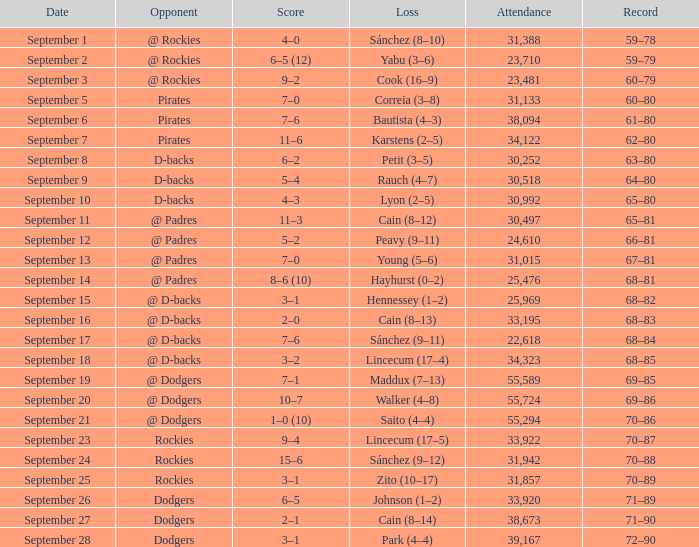What was the attendance on September 28? 39167.0. 